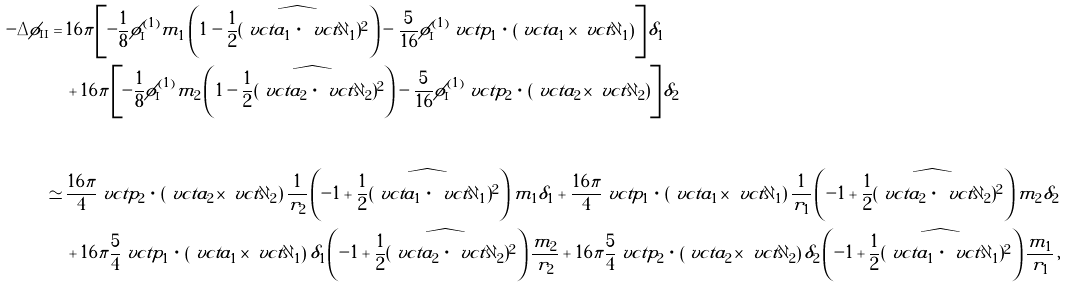Convert formula to latex. <formula><loc_0><loc_0><loc_500><loc_500>- \Delta \phi _ { \text {II} } = & \, 1 6 \pi \left [ - \frac { 1 } { 8 } \phi _ { \text {I} } ^ { ( 1 ) } m _ { 1 } \left ( 1 - \widehat { \frac { 1 } { 2 } ( \ v c t { a } _ { 1 } \, \cdot \, \ v c t { \partial } _ { 1 } ) ^ { 2 } } \right ) - \frac { 5 } { 1 6 } \phi _ { \text {I} } ^ { ( 1 ) } \ v c t { p } _ { 1 } \, \cdot \, \left ( \ v c t { a } _ { 1 } \times \ v c t { \partial } _ { 1 } \right ) \right ] \delta _ { 1 } \\ & \, + 1 6 \pi \left [ - \frac { 1 } { 8 } \phi _ { \text {I} } ^ { ( 1 ) } m _ { 2 } \left ( 1 - \widehat { \frac { 1 } { 2 } ( \ v c t { a } _ { 2 } \, \cdot \, \ v c t { \partial } _ { 2 } ) ^ { 2 } } \right ) - \frac { 5 } { 1 6 } \phi _ { \text {I} } ^ { ( 1 ) } \ v c t { p } _ { 2 } \, \cdot \, \left ( \ v c t { a } _ { 2 } \times \ v c t { \partial } _ { 2 } \right ) \right ] \delta _ { 2 } \\ \\ \simeq & \, \frac { 1 6 \pi } { 4 } \ v c t { p } _ { 2 } \, \cdot \, \left ( \ v c t { a } _ { 2 } \times \ v c t { \partial } _ { 2 } \right ) \frac { 1 } { r _ { 2 } } \left ( - 1 + \widehat { \frac { 1 } { 2 } ( \ v c t { a } _ { 1 } \, \cdot \, \ v c t { \partial } _ { 1 } ) ^ { 2 } } \right ) m _ { 1 } \delta _ { 1 } + \frac { 1 6 \pi } { 4 } \ v c t { p } _ { 1 } \, \cdot \, \left ( \ v c t { a } _ { 1 } \times \ v c t { \partial } _ { 1 } \right ) \frac { 1 } { r _ { 1 } } \left ( - 1 + \widehat { \frac { 1 } { 2 } ( \ v c t { a } _ { 2 } \, \cdot \, \ v c t { \partial } _ { 2 } ) ^ { 2 } } \right ) m _ { 2 } \delta _ { 2 } \\ & \, + 1 6 \pi \frac { 5 } { 4 } \ v c t { p } _ { 1 } \, \cdot \, \left ( \ v c t { a } _ { 1 } \times \ v c t { \partial } _ { 1 } \right ) \delta _ { 1 } \left ( - 1 + \widehat { \frac { 1 } { 2 } ( \ v c t { a } _ { 2 } \, \cdot \, \ v c t { \partial } _ { 2 } ) ^ { 2 } } \right ) \frac { m _ { 2 } } { r _ { 2 } } + 1 6 \pi \frac { 5 } { 4 } \ v c t { p } _ { 2 } \, \cdot \, \left ( \ v c t { a } _ { 2 } \times \ v c t { \partial } _ { 2 } \right ) \delta _ { 2 } \left ( - 1 + \widehat { \frac { 1 } { 2 } ( \ v c t { a } _ { 1 } \, \cdot \, \ v c t { \partial } _ { 1 } ) ^ { 2 } } \right ) \frac { m _ { 1 } } { r _ { 1 } } \, ,</formula> 